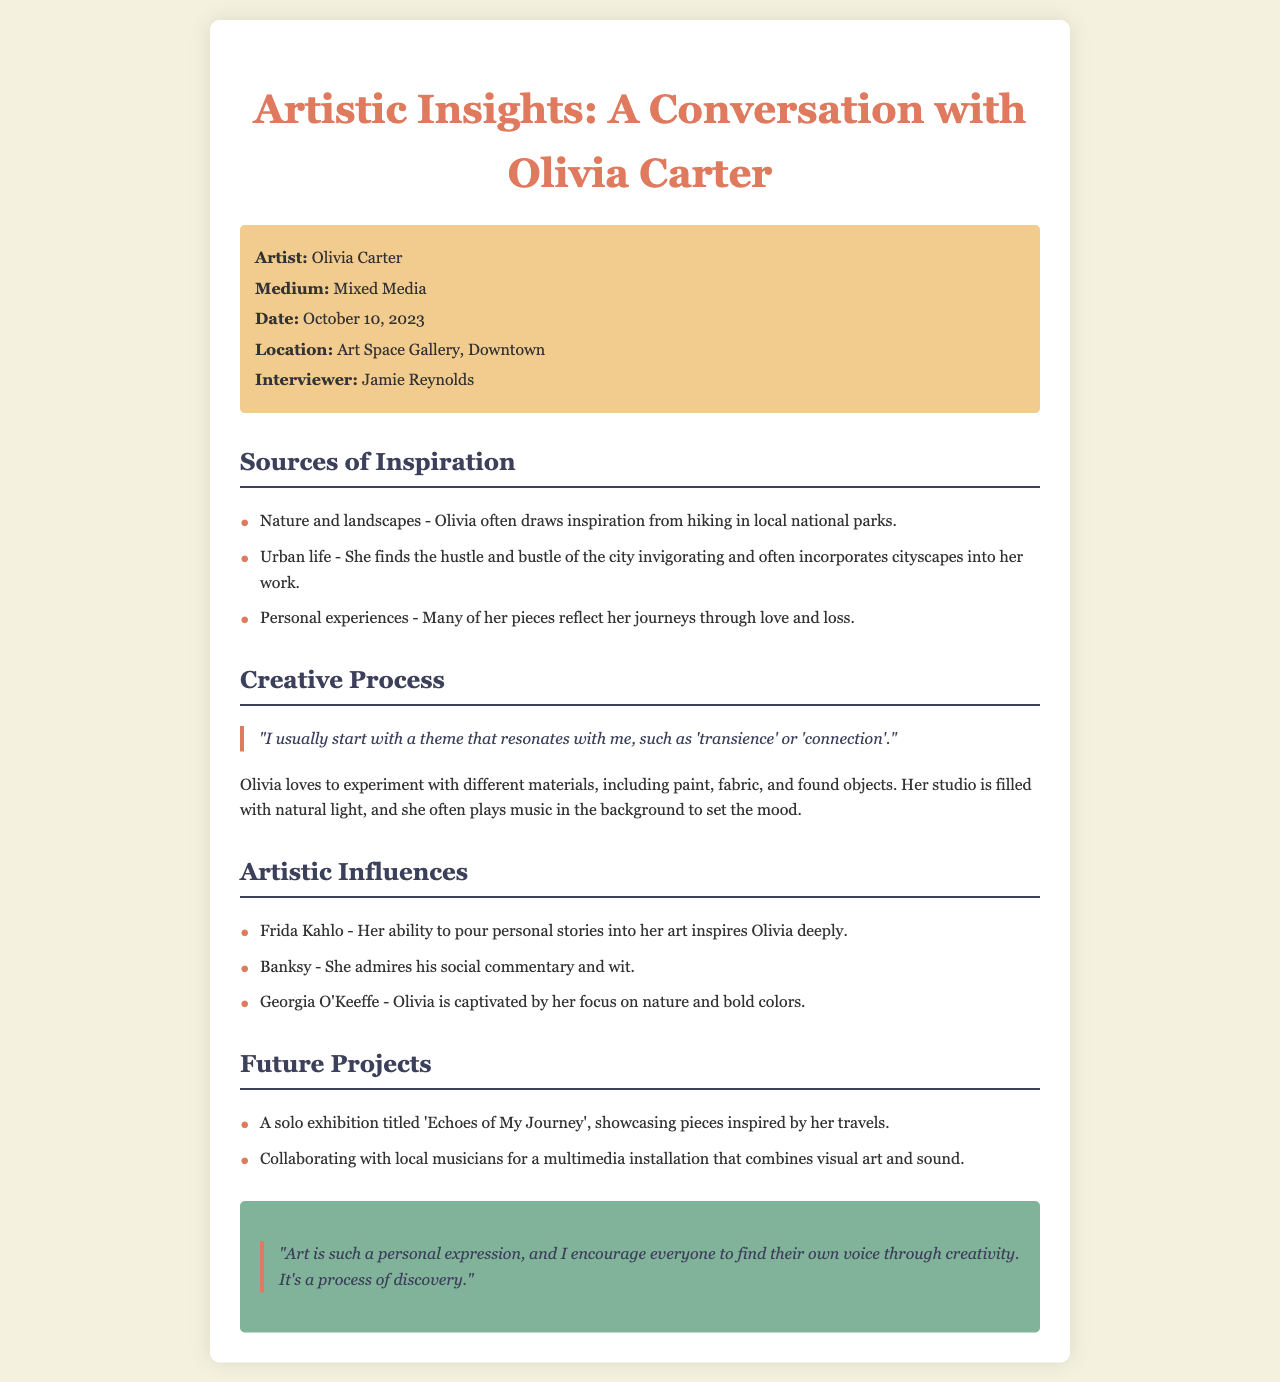What is the artist's name? The document states the artist's name as Olivia Carter.
Answer: Olivia Carter What is the medium used by Olivia Carter? The document specifies that Olivia Carter uses mixed media.
Answer: Mixed Media When was the interview conducted? The date of the interview mentioned in the document is October 10, 2023.
Answer: October 10, 2023 What is the title of Olivia's future solo exhibition? The document details a solo exhibition titled 'Echoes of My Journey'.
Answer: Echoes of My Journey Which artist deeply inspires Olivia with her personal storytelling? The document indicates that Frida Kahlo inspires Olivia deeply with her ability to pour personal stories into her art.
Answer: Frida Kahlo What theme does Olivia usually start with in her creative process? The document quotes Olivia saying she starts with a theme that resonates, such as 'transience' or 'connection'.
Answer: transience or connection What two elements does Olivia plan to combine for her multimedia installation? According to the document, Olivia plans to combine visual art and sound in her multimedia installation.
Answer: visual art and sound Where is Olivia's studio located? The document notes that Olivia's studio is filled with natural light, but does not specify a location. Thus, the answer is not directly provided in the document.
Answer: Not specified What does Olivia encourage others to find through creativity? Olivia emphasizes that she encourages everyone to find their own voice through creativity.
Answer: their own voice 